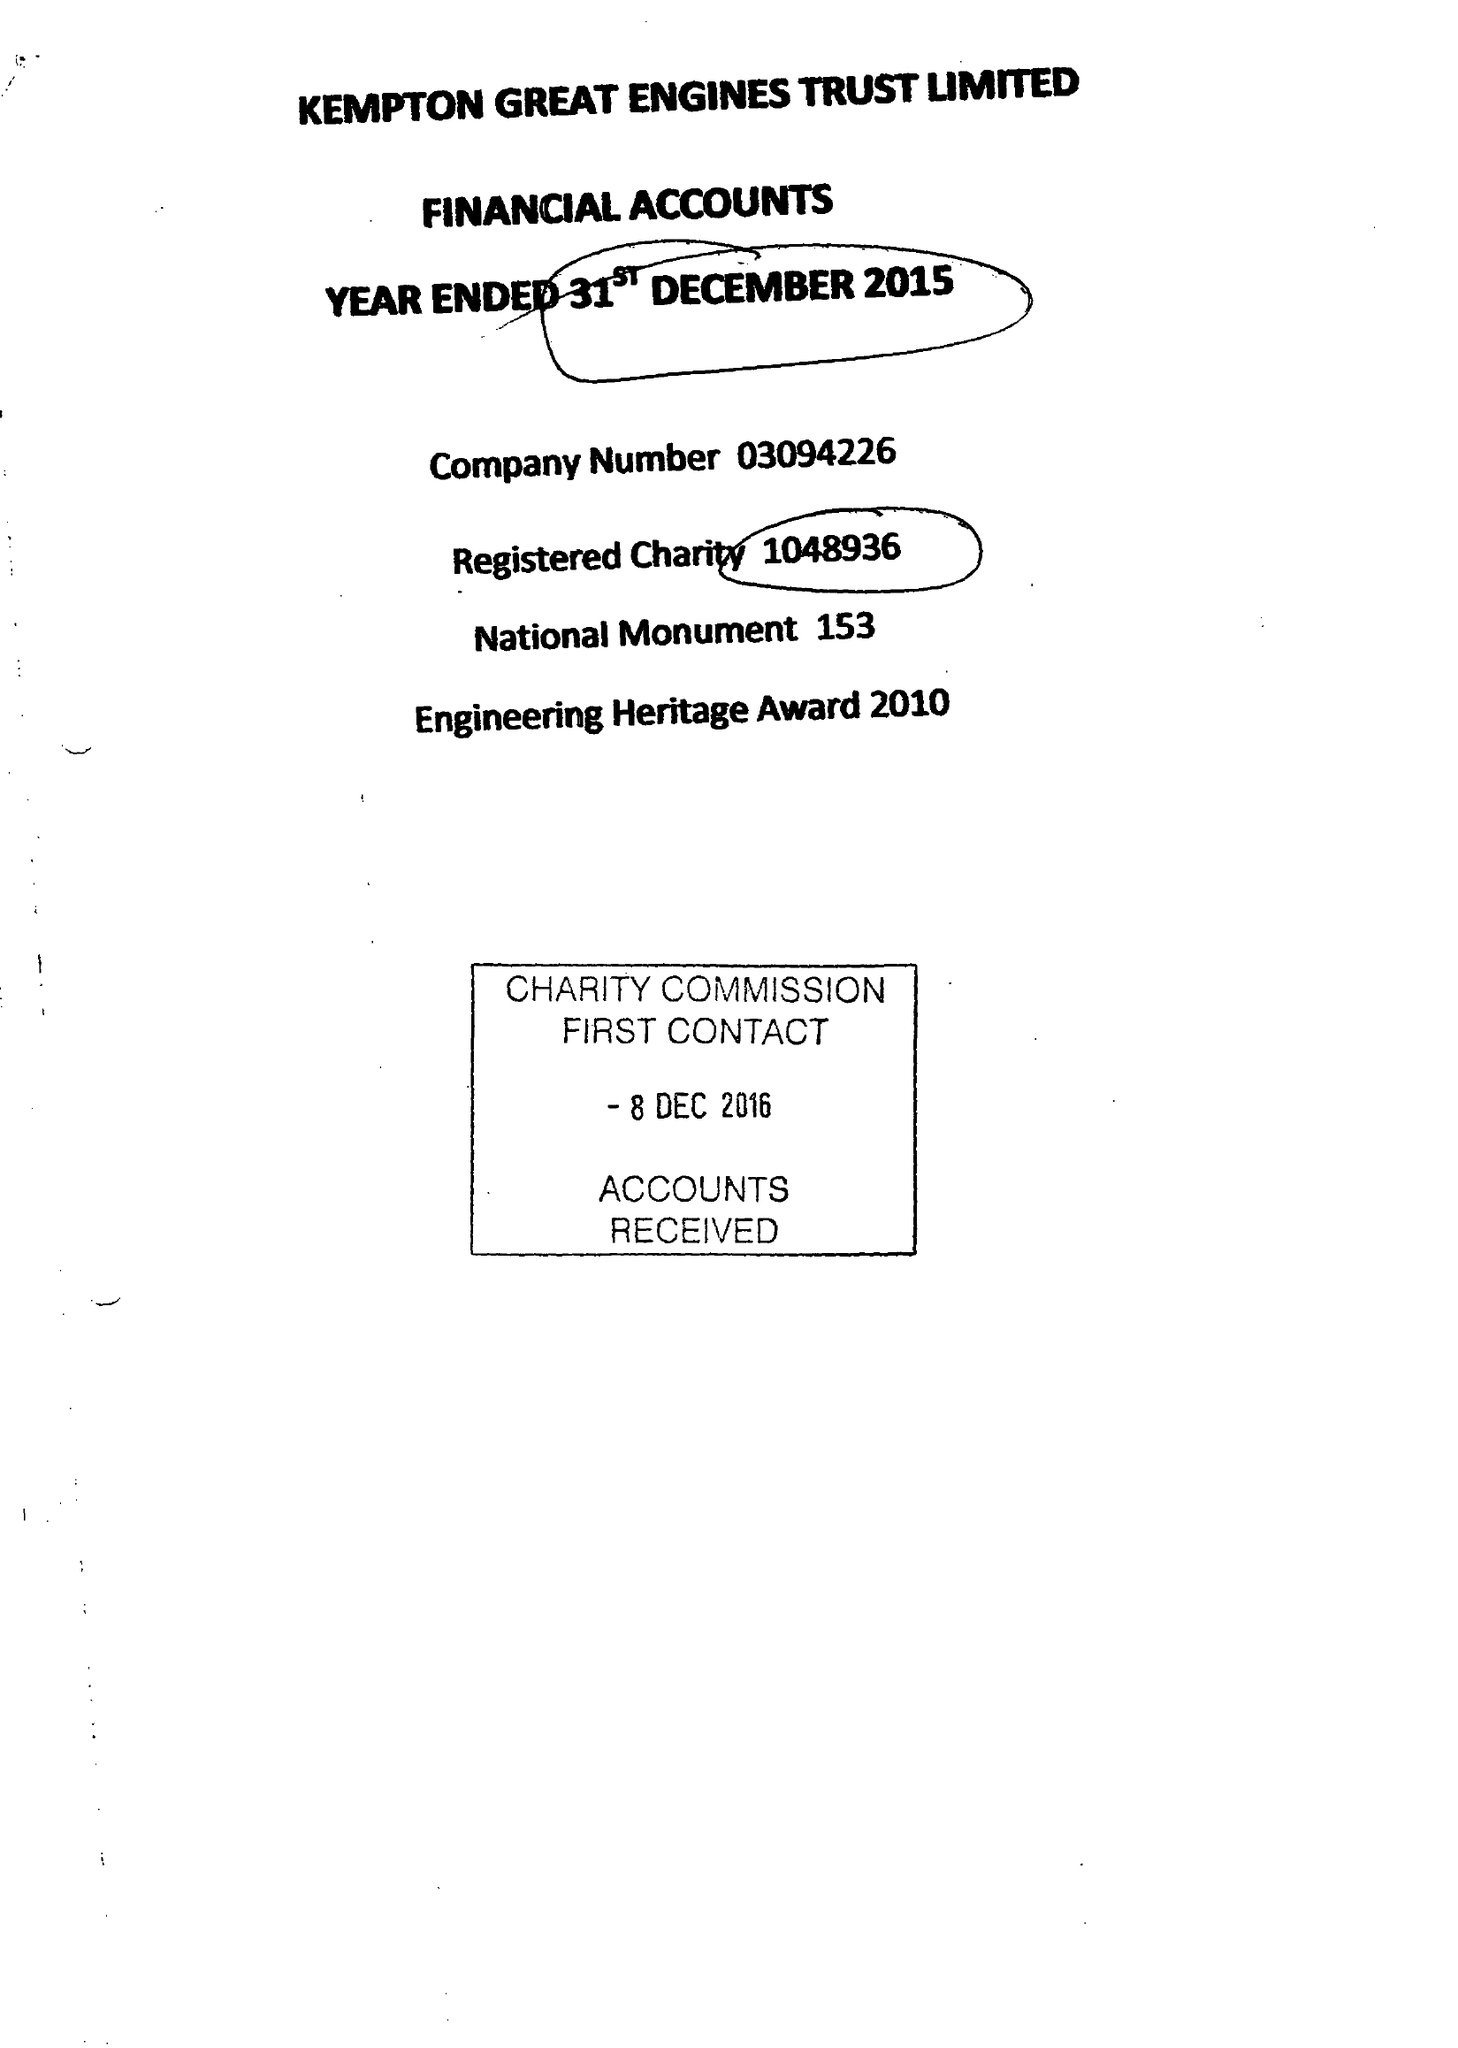What is the value for the income_annually_in_british_pounds?
Answer the question using a single word or phrase. 40273.00 